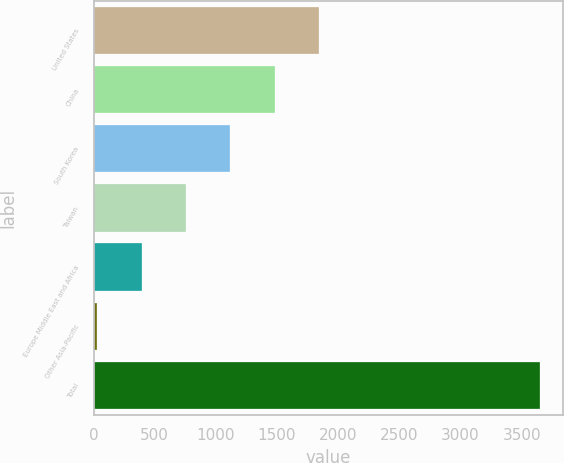<chart> <loc_0><loc_0><loc_500><loc_500><bar_chart><fcel>United States<fcel>China<fcel>South Korea<fcel>Taiwan<fcel>Europe Middle East and Africa<fcel>Other Asia-Pacific<fcel>Total<nl><fcel>1842<fcel>1480.12<fcel>1118.24<fcel>756.36<fcel>394.48<fcel>32.6<fcel>3651.4<nl></chart> 